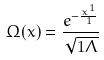Convert formula to latex. <formula><loc_0><loc_0><loc_500><loc_500>\Omega ( x ) = \frac { e ^ { - \frac { x ^ { 1 } } { 1 } } } { \sqrt { 1 \Lambda } }</formula> 